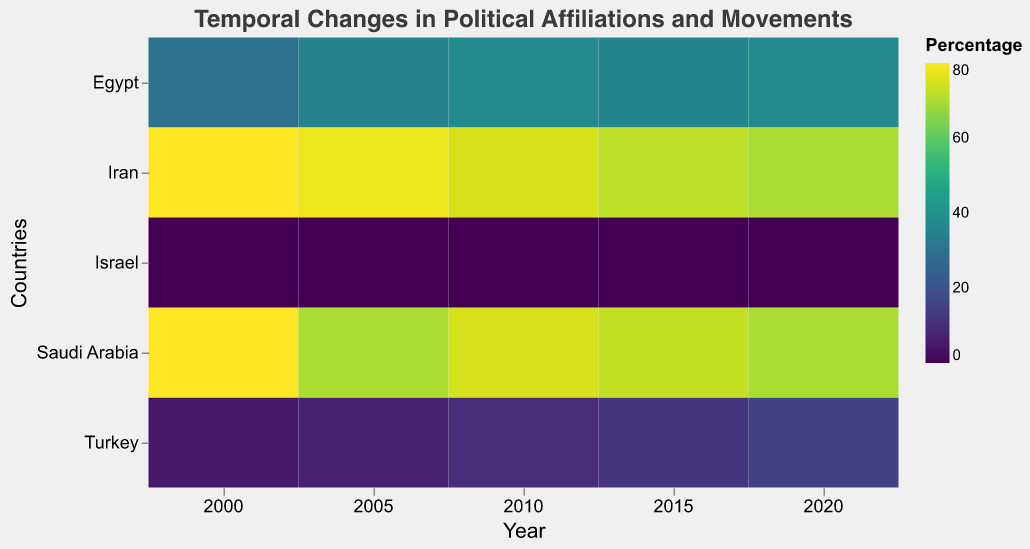What is the highest percentage of Shias in any country in the year 2000? To find the highest percentage of Shias in the year 2000, we look at the respective values across all countries for that year. We see Iran has the highest percentage with 80%.
Answer: 80% How did the percentage of Secularists change in Turkey between 2000 and 2020? To determine the change, we look at the values for Secularists in Turkey for the years 2000 (25%) and 2020 (35%). The change is 35% - 25% = 10%.
Answer: Increased by 10% Which country had the highest percentage of Christians in 2010? For the year 2010, we compare the percentage of Christians across all countries. Israel had the highest with 65%.
Answer: Israel In which year did Iran have the lowest percentage of Sunnis? By examining the values for Sunnis in Iran across the years, we find that the lowest percentage for Sunnis was 5% in 2000.
Answer: 2000 Did the percentage of Nationalists in Egypt increase or decrease between 2005 and 2015? We check the Nationalists' percentages in Egypt for 2005 (12%) and 2015 (12%). The percentage remained the same.
Answer: Remained the same What was the average percentage of Islamists in Saudi Arabia from 2000 to 2020? To find the average, add the values for Islamists in Saudi Arabia over the years 2000 (5%), 2005 (3%), 2010 (2%), 2015 (2%), and 2020 (3%). The sum is 5+3+2+2+3 = 15. The average is 15/5 = 3%.
Answer: 3% Compare the percentage of Secularists in Turkey and Egypt in 2020. Which country had a higher percentage? We look at the percentages of Secularists in 2020 for Turkey (35%) and Egypt (20%). Turkey had a higher percentage.
Answer: Turkey How does the heatmap visually represent the temporal change of Shia percentages across countries? The heatmap uses color intensity to represent the percentage values of Shias across different years and countries. Brighter colors indicate higher percentages, allowing us to easily observe changes over time. For instance, Iran consistently shows high values with darker colors.
Answer: By color intensity What trends do you observe for the percentage of Shias in Saudi Arabia from 2000 to 2020? By examining the color changes for Saudi Arabia from 2000 to 2020, we observe a slight decrease in the percentage of Shias from 80% in 2000 to 70% in 2020.
Answer: Decreasing trend 